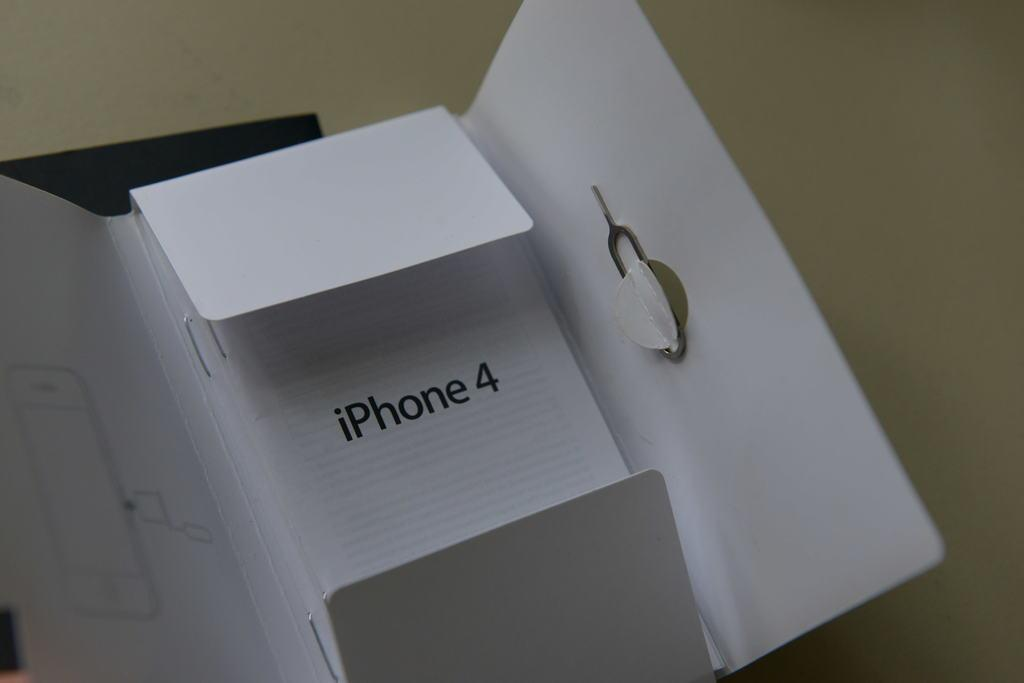<image>
Relay a brief, clear account of the picture shown. a box with iPhone 4 on the cover of it 